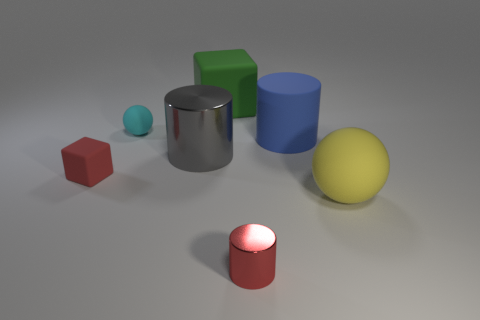Subtract all gray cylinders. How many cylinders are left? 2 Add 2 big gray metal cylinders. How many objects exist? 9 Subtract all cyan spheres. How many spheres are left? 1 Subtract 1 blocks. How many blocks are left? 1 Subtract all blocks. How many objects are left? 5 Subtract all gray balls. Subtract all brown cubes. How many balls are left? 2 Subtract all green balls. How many cyan cylinders are left? 0 Subtract all green cubes. Subtract all tiny rubber things. How many objects are left? 4 Add 5 small objects. How many small objects are left? 8 Add 2 small brown objects. How many small brown objects exist? 2 